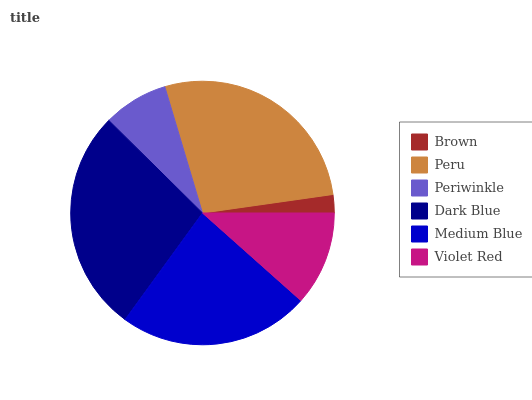Is Brown the minimum?
Answer yes or no. Yes. Is Dark Blue the maximum?
Answer yes or no. Yes. Is Peru the minimum?
Answer yes or no. No. Is Peru the maximum?
Answer yes or no. No. Is Peru greater than Brown?
Answer yes or no. Yes. Is Brown less than Peru?
Answer yes or no. Yes. Is Brown greater than Peru?
Answer yes or no. No. Is Peru less than Brown?
Answer yes or no. No. Is Medium Blue the high median?
Answer yes or no. Yes. Is Violet Red the low median?
Answer yes or no. Yes. Is Violet Red the high median?
Answer yes or no. No. Is Medium Blue the low median?
Answer yes or no. No. 